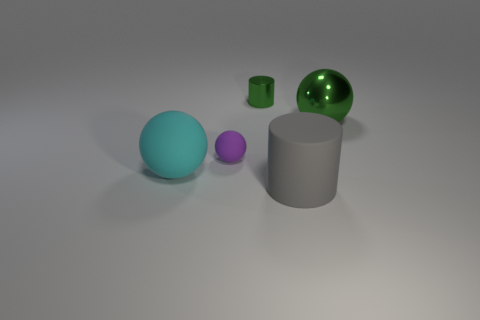Can you describe the lighting in the scene? The lighting in the scene is soft and diffused, coming from overhead, possibly simulating a natural light source like an overcast sky. The direction of the shadows indicates a single light source, creating gentle shadows that add depth without harsh contrasts. 